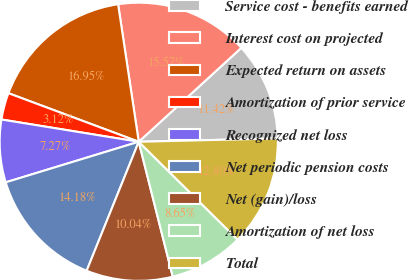<chart> <loc_0><loc_0><loc_500><loc_500><pie_chart><fcel>Service cost - benefits earned<fcel>Interest cost on projected<fcel>Expected return on assets<fcel>Amortization of prior service<fcel>Recognized net loss<fcel>Net periodic pension costs<fcel>Net (gain)/loss<fcel>Amortization of net loss<fcel>Total<nl><fcel>11.42%<fcel>15.57%<fcel>16.95%<fcel>3.12%<fcel>7.27%<fcel>14.18%<fcel>10.04%<fcel>8.65%<fcel>12.8%<nl></chart> 